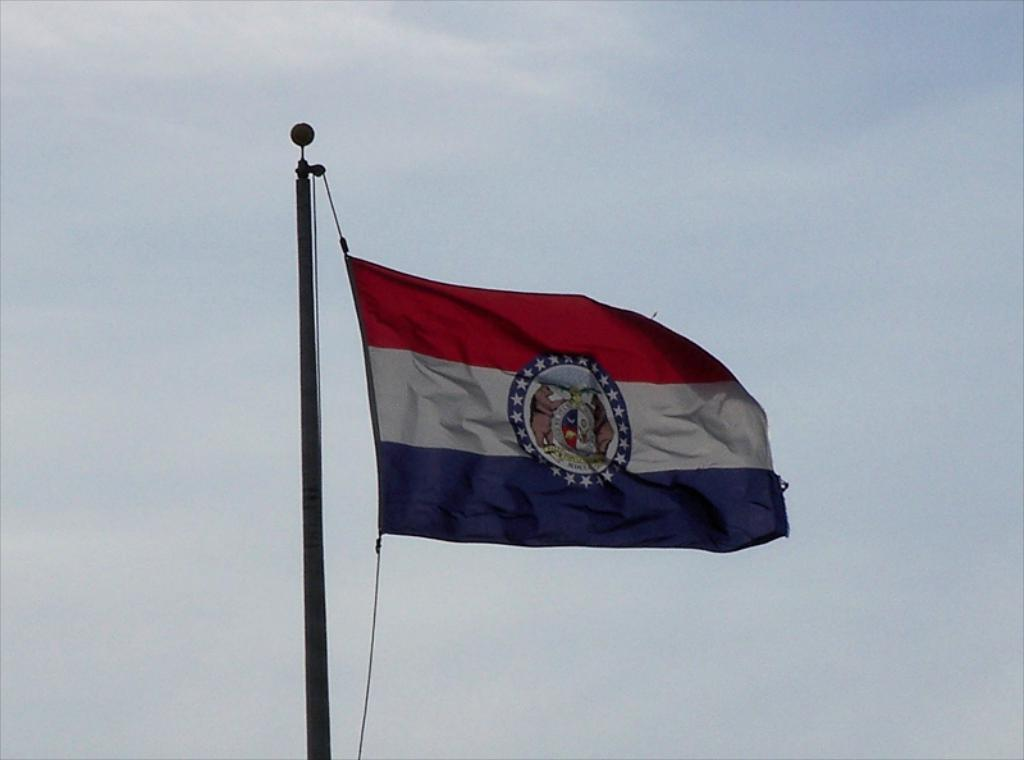What is the main object in the image? There is a flag in the image. How is the flag supported or held up? The flag is attached to a pole. What can be seen in the background of the image? The sky is visible in the image. What type of drug is the flag representative of in the image? There is no indication in the image that the flag represents any type of drug. 